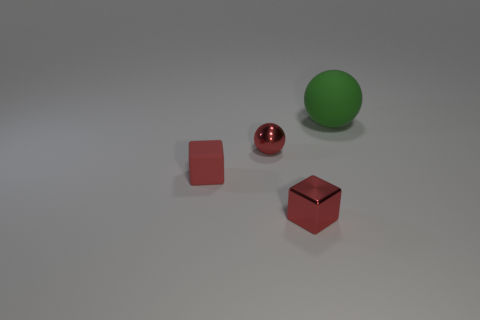Are there any other things that are the same size as the green thing?
Keep it short and to the point. No. There is a tiny metallic thing that is on the left side of the metal thing in front of the rubber object in front of the green sphere; what is its shape?
Provide a short and direct response. Sphere. Is the number of matte objects behind the tiny matte block the same as the number of rubber blocks?
Your answer should be very brief. Yes. Is the red metallic ball the same size as the green ball?
Your answer should be compact. No. What is the material of the red thing that is right of the tiny rubber thing and behind the small red metal block?
Your response must be concise. Metal. What number of small red shiny objects have the same shape as the red rubber object?
Make the answer very short. 1. What is the red cube to the right of the tiny red ball made of?
Give a very brief answer. Metal. Are there fewer green matte balls on the left side of the big green object than red blocks?
Offer a very short reply. Yes. Does the large object have the same shape as the small red rubber thing?
Ensure brevity in your answer.  No. Is there anything else that has the same shape as the green object?
Offer a very short reply. Yes. 